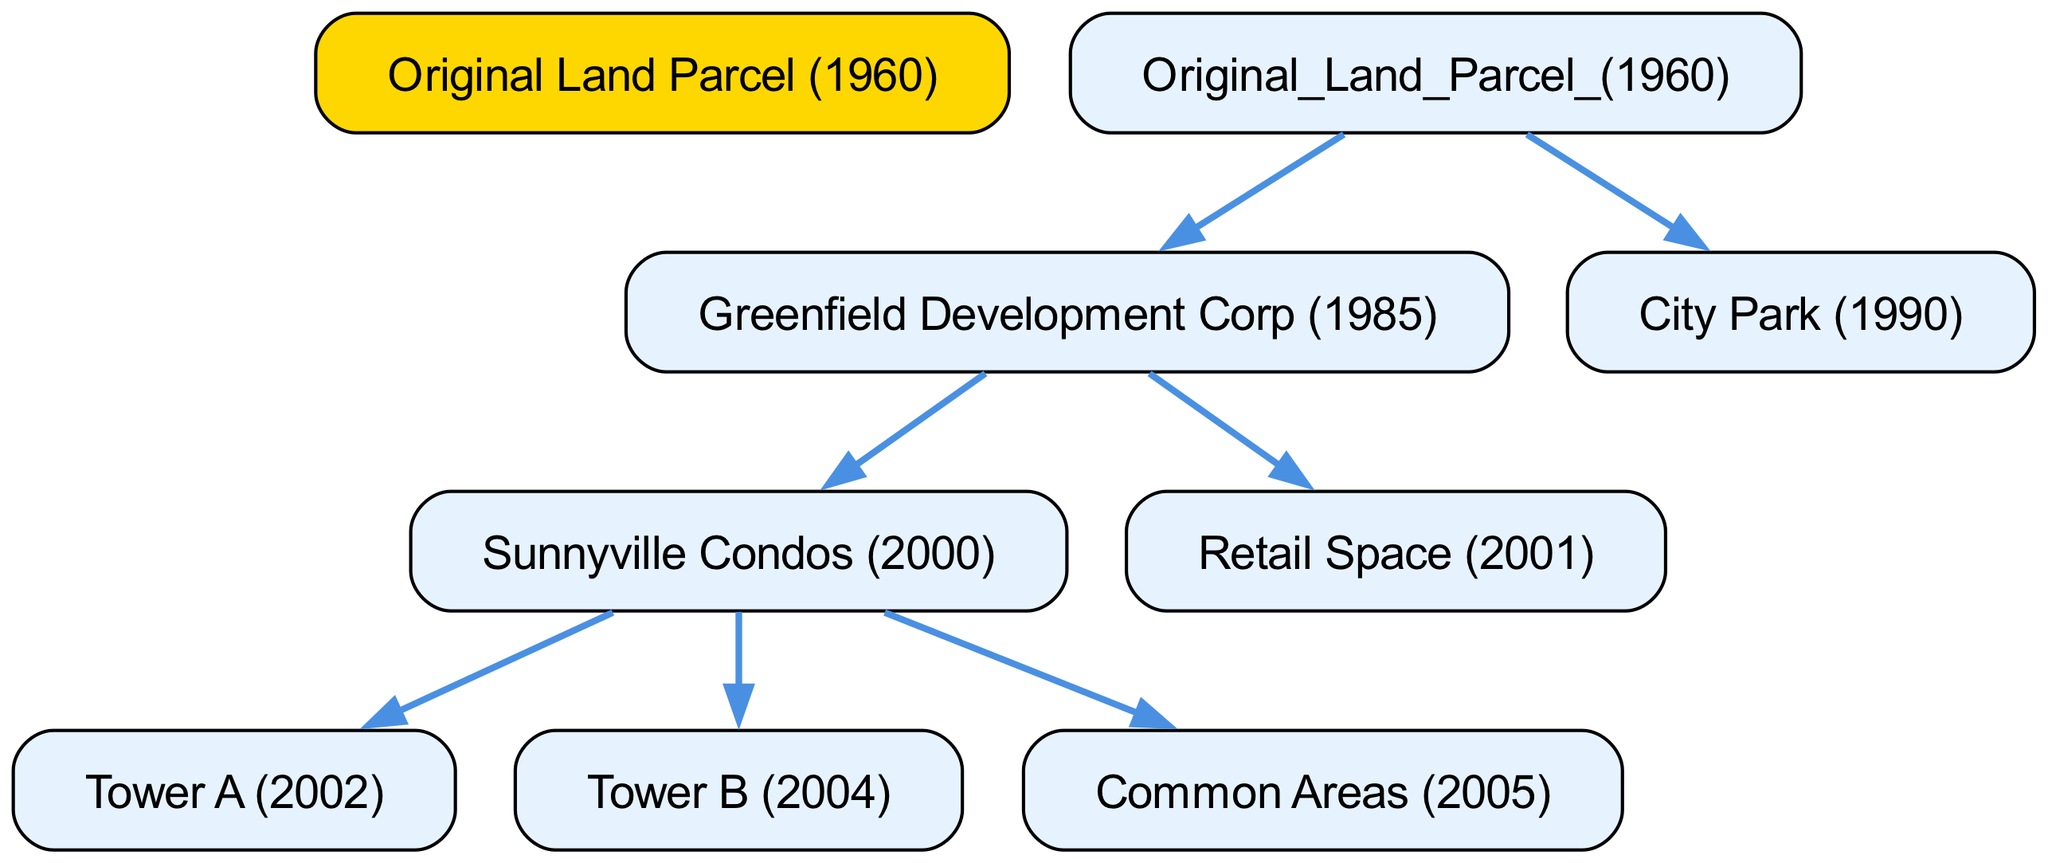What is the name of the original land parcel? The root of the diagram represents the original land parcel from which everything began, and it is labeled as "Original Land Parcel (1960)."
Answer: Original Land Parcel (1960) How many towers were built in Sunnyville Condos? The diagram shows that within the Sunnyville Condos, there are two towers listed: "Tower A" and "Tower B." This counts to a total of two towers.
Answer: 2 What year was City Park established? The diagram refers to "City Park (1990)" indicating that the establishment of City Park took place in the year 1990.
Answer: 1990 What is the relationship between Greenfield Development Corp and Sunnyville Condos? Greenfield Development Corp is a parent node to Sunnyville Condos, meaning it oversees or is responsible for its development, as shown by their direct connection in the diagram.
Answer: Parent Which structure was completed last in Sunnyville Condos? The diagram illustrates that the "Common Areas" were completed in 2005, which is after the completion of both towers and places it as the last construction in Sunnyville Condos.
Answer: Common Areas (2005) How many total child nodes does the original land parcel have? The original land parcel comprises two direct children: "Greenfield Development Corp" and "City Park." Therefore, the total count of child nodes is two.
Answer: 2 Which development occurred in the same year as Retail Space? Both "Sunnyville Condos" and "Retail Space" occurred after the acquisition of Greenfield Development Corp in 1985; however, the Retail Space specifically was completed in 2001, showing it aligns with the timeline in the diagram.
Answer: 2001 What color represents the original land parcel in the diagram? The original land parcel node is highlighted with the fill color specified in the diagram, which is "FFD700," corresponding to a gold color, making it stand out among other nodes.
Answer: Gold 